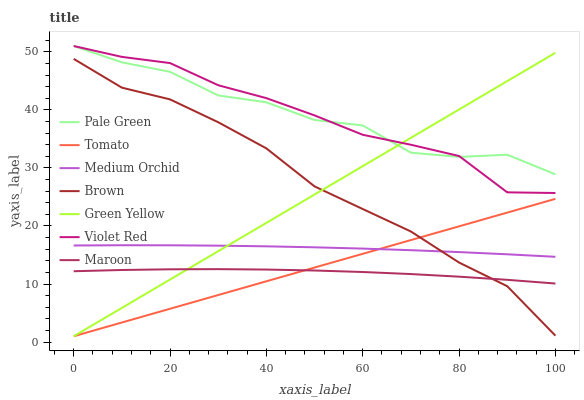Does Maroon have the minimum area under the curve?
Answer yes or no. Yes. Does Pale Green have the maximum area under the curve?
Answer yes or no. Yes. Does Brown have the minimum area under the curve?
Answer yes or no. No. Does Brown have the maximum area under the curve?
Answer yes or no. No. Is Tomato the smoothest?
Answer yes or no. Yes. Is Pale Green the roughest?
Answer yes or no. Yes. Is Brown the smoothest?
Answer yes or no. No. Is Brown the roughest?
Answer yes or no. No. Does Tomato have the lowest value?
Answer yes or no. Yes. Does Brown have the lowest value?
Answer yes or no. No. Does Pale Green have the highest value?
Answer yes or no. Yes. Does Brown have the highest value?
Answer yes or no. No. Is Medium Orchid less than Pale Green?
Answer yes or no. Yes. Is Medium Orchid greater than Maroon?
Answer yes or no. Yes. Does Brown intersect Medium Orchid?
Answer yes or no. Yes. Is Brown less than Medium Orchid?
Answer yes or no. No. Is Brown greater than Medium Orchid?
Answer yes or no. No. Does Medium Orchid intersect Pale Green?
Answer yes or no. No. 